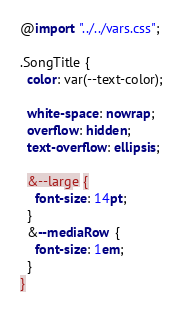<code> <loc_0><loc_0><loc_500><loc_500><_CSS_>@import "../../vars.css";

.SongTitle {
  color: var(--text-color);

  white-space: nowrap;
  overflow: hidden;
  text-overflow: ellipsis;

  &--large {
    font-size: 14pt;
  }
  &--mediaRow {
    font-size: 1em;
  }
}
</code> 